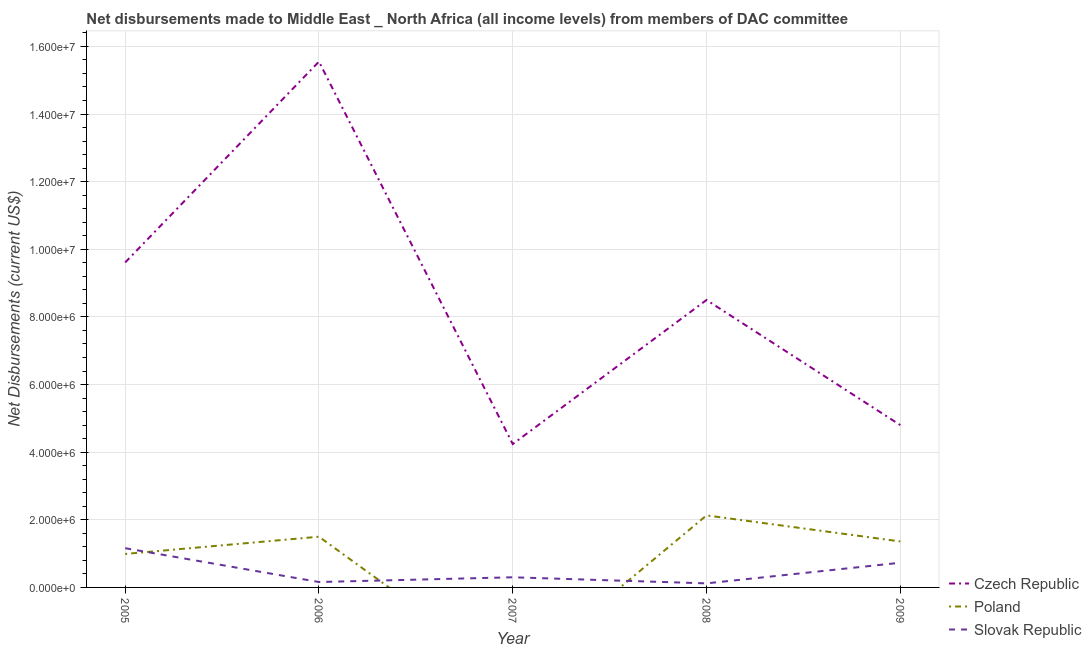How many different coloured lines are there?
Your answer should be compact. 3. What is the net disbursements made by poland in 2006?
Your answer should be compact. 1.50e+06. Across all years, what is the maximum net disbursements made by poland?
Keep it short and to the point. 2.13e+06. Across all years, what is the minimum net disbursements made by czech republic?
Give a very brief answer. 4.24e+06. In which year was the net disbursements made by poland maximum?
Ensure brevity in your answer.  2008. What is the total net disbursements made by slovak republic in the graph?
Give a very brief answer. 2.47e+06. What is the difference between the net disbursements made by slovak republic in 2006 and that in 2008?
Provide a succinct answer. 4.00e+04. What is the difference between the net disbursements made by czech republic in 2008 and the net disbursements made by slovak republic in 2005?
Ensure brevity in your answer.  7.34e+06. What is the average net disbursements made by slovak republic per year?
Your response must be concise. 4.94e+05. In the year 2008, what is the difference between the net disbursements made by czech republic and net disbursements made by slovak republic?
Offer a very short reply. 8.38e+06. What is the ratio of the net disbursements made by poland in 2005 to that in 2008?
Give a very brief answer. 0.46. Is the net disbursements made by czech republic in 2008 less than that in 2009?
Provide a short and direct response. No. What is the difference between the highest and the second highest net disbursements made by czech republic?
Your answer should be compact. 5.94e+06. What is the difference between the highest and the lowest net disbursements made by slovak republic?
Keep it short and to the point. 1.04e+06. In how many years, is the net disbursements made by czech republic greater than the average net disbursements made by czech republic taken over all years?
Offer a terse response. 2. Is it the case that in every year, the sum of the net disbursements made by czech republic and net disbursements made by poland is greater than the net disbursements made by slovak republic?
Keep it short and to the point. Yes. Does the net disbursements made by poland monotonically increase over the years?
Make the answer very short. No. Are the values on the major ticks of Y-axis written in scientific E-notation?
Your response must be concise. Yes. Does the graph contain grids?
Give a very brief answer. Yes. How are the legend labels stacked?
Offer a terse response. Vertical. What is the title of the graph?
Keep it short and to the point. Net disbursements made to Middle East _ North Africa (all income levels) from members of DAC committee. What is the label or title of the Y-axis?
Provide a short and direct response. Net Disbursements (current US$). What is the Net Disbursements (current US$) in Czech Republic in 2005?
Your answer should be very brief. 9.61e+06. What is the Net Disbursements (current US$) in Poland in 2005?
Offer a very short reply. 9.90e+05. What is the Net Disbursements (current US$) in Slovak Republic in 2005?
Give a very brief answer. 1.16e+06. What is the Net Disbursements (current US$) of Czech Republic in 2006?
Keep it short and to the point. 1.56e+07. What is the Net Disbursements (current US$) of Poland in 2006?
Offer a terse response. 1.50e+06. What is the Net Disbursements (current US$) of Slovak Republic in 2006?
Offer a very short reply. 1.60e+05. What is the Net Disbursements (current US$) in Czech Republic in 2007?
Your answer should be compact. 4.24e+06. What is the Net Disbursements (current US$) of Slovak Republic in 2007?
Make the answer very short. 3.00e+05. What is the Net Disbursements (current US$) of Czech Republic in 2008?
Your answer should be very brief. 8.50e+06. What is the Net Disbursements (current US$) of Poland in 2008?
Give a very brief answer. 2.13e+06. What is the Net Disbursements (current US$) in Czech Republic in 2009?
Your response must be concise. 4.80e+06. What is the Net Disbursements (current US$) of Poland in 2009?
Your response must be concise. 1.36e+06. What is the Net Disbursements (current US$) in Slovak Republic in 2009?
Give a very brief answer. 7.30e+05. Across all years, what is the maximum Net Disbursements (current US$) in Czech Republic?
Your answer should be compact. 1.56e+07. Across all years, what is the maximum Net Disbursements (current US$) of Poland?
Make the answer very short. 2.13e+06. Across all years, what is the maximum Net Disbursements (current US$) of Slovak Republic?
Provide a succinct answer. 1.16e+06. Across all years, what is the minimum Net Disbursements (current US$) of Czech Republic?
Provide a short and direct response. 4.24e+06. What is the total Net Disbursements (current US$) in Czech Republic in the graph?
Ensure brevity in your answer.  4.27e+07. What is the total Net Disbursements (current US$) of Poland in the graph?
Ensure brevity in your answer.  5.98e+06. What is the total Net Disbursements (current US$) in Slovak Republic in the graph?
Offer a very short reply. 2.47e+06. What is the difference between the Net Disbursements (current US$) in Czech Republic in 2005 and that in 2006?
Provide a succinct answer. -5.94e+06. What is the difference between the Net Disbursements (current US$) in Poland in 2005 and that in 2006?
Your response must be concise. -5.10e+05. What is the difference between the Net Disbursements (current US$) of Slovak Republic in 2005 and that in 2006?
Give a very brief answer. 1.00e+06. What is the difference between the Net Disbursements (current US$) in Czech Republic in 2005 and that in 2007?
Make the answer very short. 5.37e+06. What is the difference between the Net Disbursements (current US$) of Slovak Republic in 2005 and that in 2007?
Provide a short and direct response. 8.60e+05. What is the difference between the Net Disbursements (current US$) of Czech Republic in 2005 and that in 2008?
Ensure brevity in your answer.  1.11e+06. What is the difference between the Net Disbursements (current US$) in Poland in 2005 and that in 2008?
Offer a terse response. -1.14e+06. What is the difference between the Net Disbursements (current US$) in Slovak Republic in 2005 and that in 2008?
Provide a succinct answer. 1.04e+06. What is the difference between the Net Disbursements (current US$) in Czech Republic in 2005 and that in 2009?
Make the answer very short. 4.81e+06. What is the difference between the Net Disbursements (current US$) in Poland in 2005 and that in 2009?
Your response must be concise. -3.70e+05. What is the difference between the Net Disbursements (current US$) of Czech Republic in 2006 and that in 2007?
Provide a succinct answer. 1.13e+07. What is the difference between the Net Disbursements (current US$) in Slovak Republic in 2006 and that in 2007?
Provide a short and direct response. -1.40e+05. What is the difference between the Net Disbursements (current US$) in Czech Republic in 2006 and that in 2008?
Give a very brief answer. 7.05e+06. What is the difference between the Net Disbursements (current US$) of Poland in 2006 and that in 2008?
Your answer should be compact. -6.30e+05. What is the difference between the Net Disbursements (current US$) of Slovak Republic in 2006 and that in 2008?
Offer a very short reply. 4.00e+04. What is the difference between the Net Disbursements (current US$) in Czech Republic in 2006 and that in 2009?
Keep it short and to the point. 1.08e+07. What is the difference between the Net Disbursements (current US$) in Slovak Republic in 2006 and that in 2009?
Keep it short and to the point. -5.70e+05. What is the difference between the Net Disbursements (current US$) in Czech Republic in 2007 and that in 2008?
Your answer should be very brief. -4.26e+06. What is the difference between the Net Disbursements (current US$) in Czech Republic in 2007 and that in 2009?
Offer a very short reply. -5.60e+05. What is the difference between the Net Disbursements (current US$) of Slovak Republic in 2007 and that in 2009?
Provide a succinct answer. -4.30e+05. What is the difference between the Net Disbursements (current US$) of Czech Republic in 2008 and that in 2009?
Your answer should be very brief. 3.70e+06. What is the difference between the Net Disbursements (current US$) in Poland in 2008 and that in 2009?
Offer a very short reply. 7.70e+05. What is the difference between the Net Disbursements (current US$) in Slovak Republic in 2008 and that in 2009?
Offer a terse response. -6.10e+05. What is the difference between the Net Disbursements (current US$) in Czech Republic in 2005 and the Net Disbursements (current US$) in Poland in 2006?
Your answer should be very brief. 8.11e+06. What is the difference between the Net Disbursements (current US$) of Czech Republic in 2005 and the Net Disbursements (current US$) of Slovak Republic in 2006?
Offer a terse response. 9.45e+06. What is the difference between the Net Disbursements (current US$) in Poland in 2005 and the Net Disbursements (current US$) in Slovak Republic in 2006?
Your answer should be compact. 8.30e+05. What is the difference between the Net Disbursements (current US$) of Czech Republic in 2005 and the Net Disbursements (current US$) of Slovak Republic in 2007?
Make the answer very short. 9.31e+06. What is the difference between the Net Disbursements (current US$) of Poland in 2005 and the Net Disbursements (current US$) of Slovak Republic in 2007?
Your response must be concise. 6.90e+05. What is the difference between the Net Disbursements (current US$) in Czech Republic in 2005 and the Net Disbursements (current US$) in Poland in 2008?
Offer a very short reply. 7.48e+06. What is the difference between the Net Disbursements (current US$) in Czech Republic in 2005 and the Net Disbursements (current US$) in Slovak Republic in 2008?
Offer a very short reply. 9.49e+06. What is the difference between the Net Disbursements (current US$) in Poland in 2005 and the Net Disbursements (current US$) in Slovak Republic in 2008?
Provide a succinct answer. 8.70e+05. What is the difference between the Net Disbursements (current US$) of Czech Republic in 2005 and the Net Disbursements (current US$) of Poland in 2009?
Offer a terse response. 8.25e+06. What is the difference between the Net Disbursements (current US$) in Czech Republic in 2005 and the Net Disbursements (current US$) in Slovak Republic in 2009?
Ensure brevity in your answer.  8.88e+06. What is the difference between the Net Disbursements (current US$) of Poland in 2005 and the Net Disbursements (current US$) of Slovak Republic in 2009?
Your answer should be compact. 2.60e+05. What is the difference between the Net Disbursements (current US$) in Czech Republic in 2006 and the Net Disbursements (current US$) in Slovak Republic in 2007?
Your answer should be compact. 1.52e+07. What is the difference between the Net Disbursements (current US$) of Poland in 2006 and the Net Disbursements (current US$) of Slovak Republic in 2007?
Ensure brevity in your answer.  1.20e+06. What is the difference between the Net Disbursements (current US$) in Czech Republic in 2006 and the Net Disbursements (current US$) in Poland in 2008?
Ensure brevity in your answer.  1.34e+07. What is the difference between the Net Disbursements (current US$) in Czech Republic in 2006 and the Net Disbursements (current US$) in Slovak Republic in 2008?
Offer a terse response. 1.54e+07. What is the difference between the Net Disbursements (current US$) in Poland in 2006 and the Net Disbursements (current US$) in Slovak Republic in 2008?
Your response must be concise. 1.38e+06. What is the difference between the Net Disbursements (current US$) of Czech Republic in 2006 and the Net Disbursements (current US$) of Poland in 2009?
Ensure brevity in your answer.  1.42e+07. What is the difference between the Net Disbursements (current US$) of Czech Republic in 2006 and the Net Disbursements (current US$) of Slovak Republic in 2009?
Give a very brief answer. 1.48e+07. What is the difference between the Net Disbursements (current US$) in Poland in 2006 and the Net Disbursements (current US$) in Slovak Republic in 2009?
Offer a very short reply. 7.70e+05. What is the difference between the Net Disbursements (current US$) in Czech Republic in 2007 and the Net Disbursements (current US$) in Poland in 2008?
Ensure brevity in your answer.  2.11e+06. What is the difference between the Net Disbursements (current US$) in Czech Republic in 2007 and the Net Disbursements (current US$) in Slovak Republic in 2008?
Ensure brevity in your answer.  4.12e+06. What is the difference between the Net Disbursements (current US$) in Czech Republic in 2007 and the Net Disbursements (current US$) in Poland in 2009?
Give a very brief answer. 2.88e+06. What is the difference between the Net Disbursements (current US$) of Czech Republic in 2007 and the Net Disbursements (current US$) of Slovak Republic in 2009?
Offer a very short reply. 3.51e+06. What is the difference between the Net Disbursements (current US$) of Czech Republic in 2008 and the Net Disbursements (current US$) of Poland in 2009?
Offer a terse response. 7.14e+06. What is the difference between the Net Disbursements (current US$) in Czech Republic in 2008 and the Net Disbursements (current US$) in Slovak Republic in 2009?
Keep it short and to the point. 7.77e+06. What is the difference between the Net Disbursements (current US$) in Poland in 2008 and the Net Disbursements (current US$) in Slovak Republic in 2009?
Your response must be concise. 1.40e+06. What is the average Net Disbursements (current US$) in Czech Republic per year?
Keep it short and to the point. 8.54e+06. What is the average Net Disbursements (current US$) in Poland per year?
Provide a short and direct response. 1.20e+06. What is the average Net Disbursements (current US$) of Slovak Republic per year?
Provide a short and direct response. 4.94e+05. In the year 2005, what is the difference between the Net Disbursements (current US$) in Czech Republic and Net Disbursements (current US$) in Poland?
Make the answer very short. 8.62e+06. In the year 2005, what is the difference between the Net Disbursements (current US$) in Czech Republic and Net Disbursements (current US$) in Slovak Republic?
Give a very brief answer. 8.45e+06. In the year 2006, what is the difference between the Net Disbursements (current US$) of Czech Republic and Net Disbursements (current US$) of Poland?
Your response must be concise. 1.40e+07. In the year 2006, what is the difference between the Net Disbursements (current US$) in Czech Republic and Net Disbursements (current US$) in Slovak Republic?
Offer a very short reply. 1.54e+07. In the year 2006, what is the difference between the Net Disbursements (current US$) of Poland and Net Disbursements (current US$) of Slovak Republic?
Keep it short and to the point. 1.34e+06. In the year 2007, what is the difference between the Net Disbursements (current US$) in Czech Republic and Net Disbursements (current US$) in Slovak Republic?
Ensure brevity in your answer.  3.94e+06. In the year 2008, what is the difference between the Net Disbursements (current US$) of Czech Republic and Net Disbursements (current US$) of Poland?
Give a very brief answer. 6.37e+06. In the year 2008, what is the difference between the Net Disbursements (current US$) of Czech Republic and Net Disbursements (current US$) of Slovak Republic?
Provide a succinct answer. 8.38e+06. In the year 2008, what is the difference between the Net Disbursements (current US$) in Poland and Net Disbursements (current US$) in Slovak Republic?
Make the answer very short. 2.01e+06. In the year 2009, what is the difference between the Net Disbursements (current US$) of Czech Republic and Net Disbursements (current US$) of Poland?
Keep it short and to the point. 3.44e+06. In the year 2009, what is the difference between the Net Disbursements (current US$) of Czech Republic and Net Disbursements (current US$) of Slovak Republic?
Your answer should be very brief. 4.07e+06. In the year 2009, what is the difference between the Net Disbursements (current US$) in Poland and Net Disbursements (current US$) in Slovak Republic?
Provide a succinct answer. 6.30e+05. What is the ratio of the Net Disbursements (current US$) of Czech Republic in 2005 to that in 2006?
Your response must be concise. 0.62. What is the ratio of the Net Disbursements (current US$) in Poland in 2005 to that in 2006?
Offer a very short reply. 0.66. What is the ratio of the Net Disbursements (current US$) in Slovak Republic in 2005 to that in 2006?
Provide a short and direct response. 7.25. What is the ratio of the Net Disbursements (current US$) in Czech Republic in 2005 to that in 2007?
Your response must be concise. 2.27. What is the ratio of the Net Disbursements (current US$) in Slovak Republic in 2005 to that in 2007?
Make the answer very short. 3.87. What is the ratio of the Net Disbursements (current US$) of Czech Republic in 2005 to that in 2008?
Offer a terse response. 1.13. What is the ratio of the Net Disbursements (current US$) of Poland in 2005 to that in 2008?
Provide a short and direct response. 0.46. What is the ratio of the Net Disbursements (current US$) of Slovak Republic in 2005 to that in 2008?
Give a very brief answer. 9.67. What is the ratio of the Net Disbursements (current US$) in Czech Republic in 2005 to that in 2009?
Ensure brevity in your answer.  2. What is the ratio of the Net Disbursements (current US$) in Poland in 2005 to that in 2009?
Offer a terse response. 0.73. What is the ratio of the Net Disbursements (current US$) of Slovak Republic in 2005 to that in 2009?
Provide a succinct answer. 1.59. What is the ratio of the Net Disbursements (current US$) in Czech Republic in 2006 to that in 2007?
Provide a succinct answer. 3.67. What is the ratio of the Net Disbursements (current US$) of Slovak Republic in 2006 to that in 2007?
Provide a short and direct response. 0.53. What is the ratio of the Net Disbursements (current US$) in Czech Republic in 2006 to that in 2008?
Your response must be concise. 1.83. What is the ratio of the Net Disbursements (current US$) in Poland in 2006 to that in 2008?
Provide a succinct answer. 0.7. What is the ratio of the Net Disbursements (current US$) in Slovak Republic in 2006 to that in 2008?
Offer a terse response. 1.33. What is the ratio of the Net Disbursements (current US$) in Czech Republic in 2006 to that in 2009?
Your response must be concise. 3.24. What is the ratio of the Net Disbursements (current US$) in Poland in 2006 to that in 2009?
Provide a succinct answer. 1.1. What is the ratio of the Net Disbursements (current US$) in Slovak Republic in 2006 to that in 2009?
Your answer should be very brief. 0.22. What is the ratio of the Net Disbursements (current US$) in Czech Republic in 2007 to that in 2008?
Your answer should be very brief. 0.5. What is the ratio of the Net Disbursements (current US$) of Czech Republic in 2007 to that in 2009?
Your answer should be compact. 0.88. What is the ratio of the Net Disbursements (current US$) in Slovak Republic in 2007 to that in 2009?
Give a very brief answer. 0.41. What is the ratio of the Net Disbursements (current US$) of Czech Republic in 2008 to that in 2009?
Keep it short and to the point. 1.77. What is the ratio of the Net Disbursements (current US$) of Poland in 2008 to that in 2009?
Your answer should be compact. 1.57. What is the ratio of the Net Disbursements (current US$) of Slovak Republic in 2008 to that in 2009?
Your response must be concise. 0.16. What is the difference between the highest and the second highest Net Disbursements (current US$) of Czech Republic?
Ensure brevity in your answer.  5.94e+06. What is the difference between the highest and the second highest Net Disbursements (current US$) of Poland?
Keep it short and to the point. 6.30e+05. What is the difference between the highest and the second highest Net Disbursements (current US$) of Slovak Republic?
Your answer should be compact. 4.30e+05. What is the difference between the highest and the lowest Net Disbursements (current US$) in Czech Republic?
Offer a terse response. 1.13e+07. What is the difference between the highest and the lowest Net Disbursements (current US$) of Poland?
Offer a terse response. 2.13e+06. What is the difference between the highest and the lowest Net Disbursements (current US$) in Slovak Republic?
Ensure brevity in your answer.  1.04e+06. 